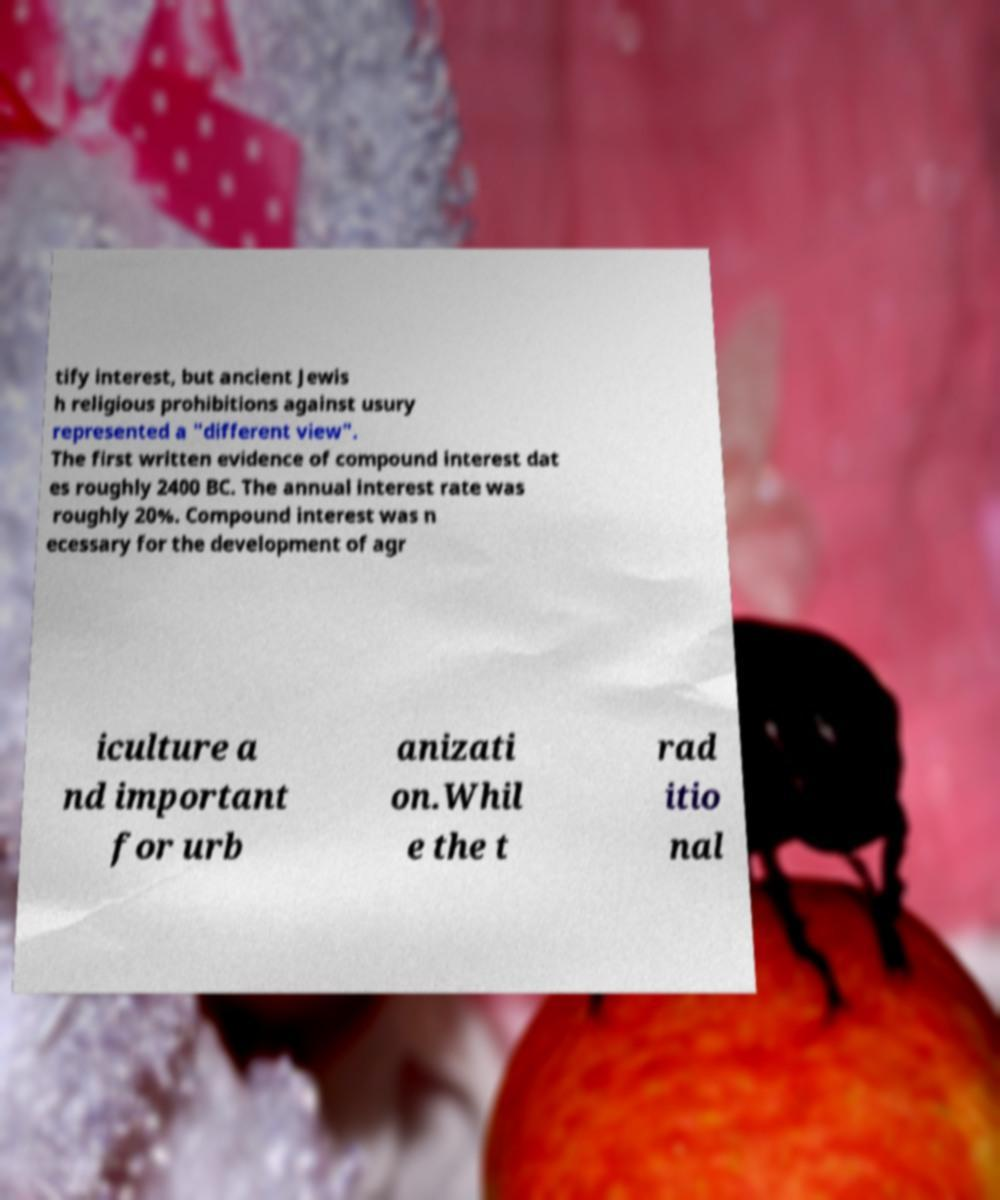Please read and relay the text visible in this image. What does it say? tify interest, but ancient Jewis h religious prohibitions against usury represented a "different view". The first written evidence of compound interest dat es roughly 2400 BC. The annual interest rate was roughly 20%. Compound interest was n ecessary for the development of agr iculture a nd important for urb anizati on.Whil e the t rad itio nal 